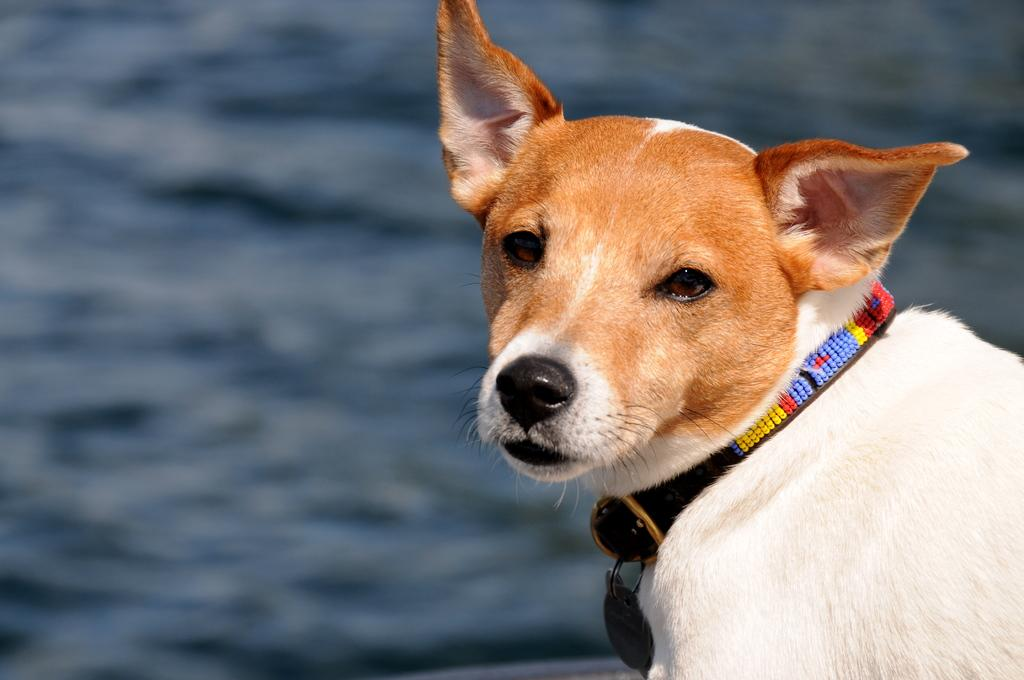What animal can be seen in the image? There is a dog in the image. Where is the dog located in the image? The dog is towards the right side of the image. What colors can be seen on the dog? The dog is brown and white in color. What is attached to the dog's neck? There is a belt on the dog's neck. What can be seen in the background of the image? There is water visible in the background of the image. How does the dog control the sorting of items in the image? The dog does not control the sorting of items in the image, as there is no indication of any sorting activity taking place. 